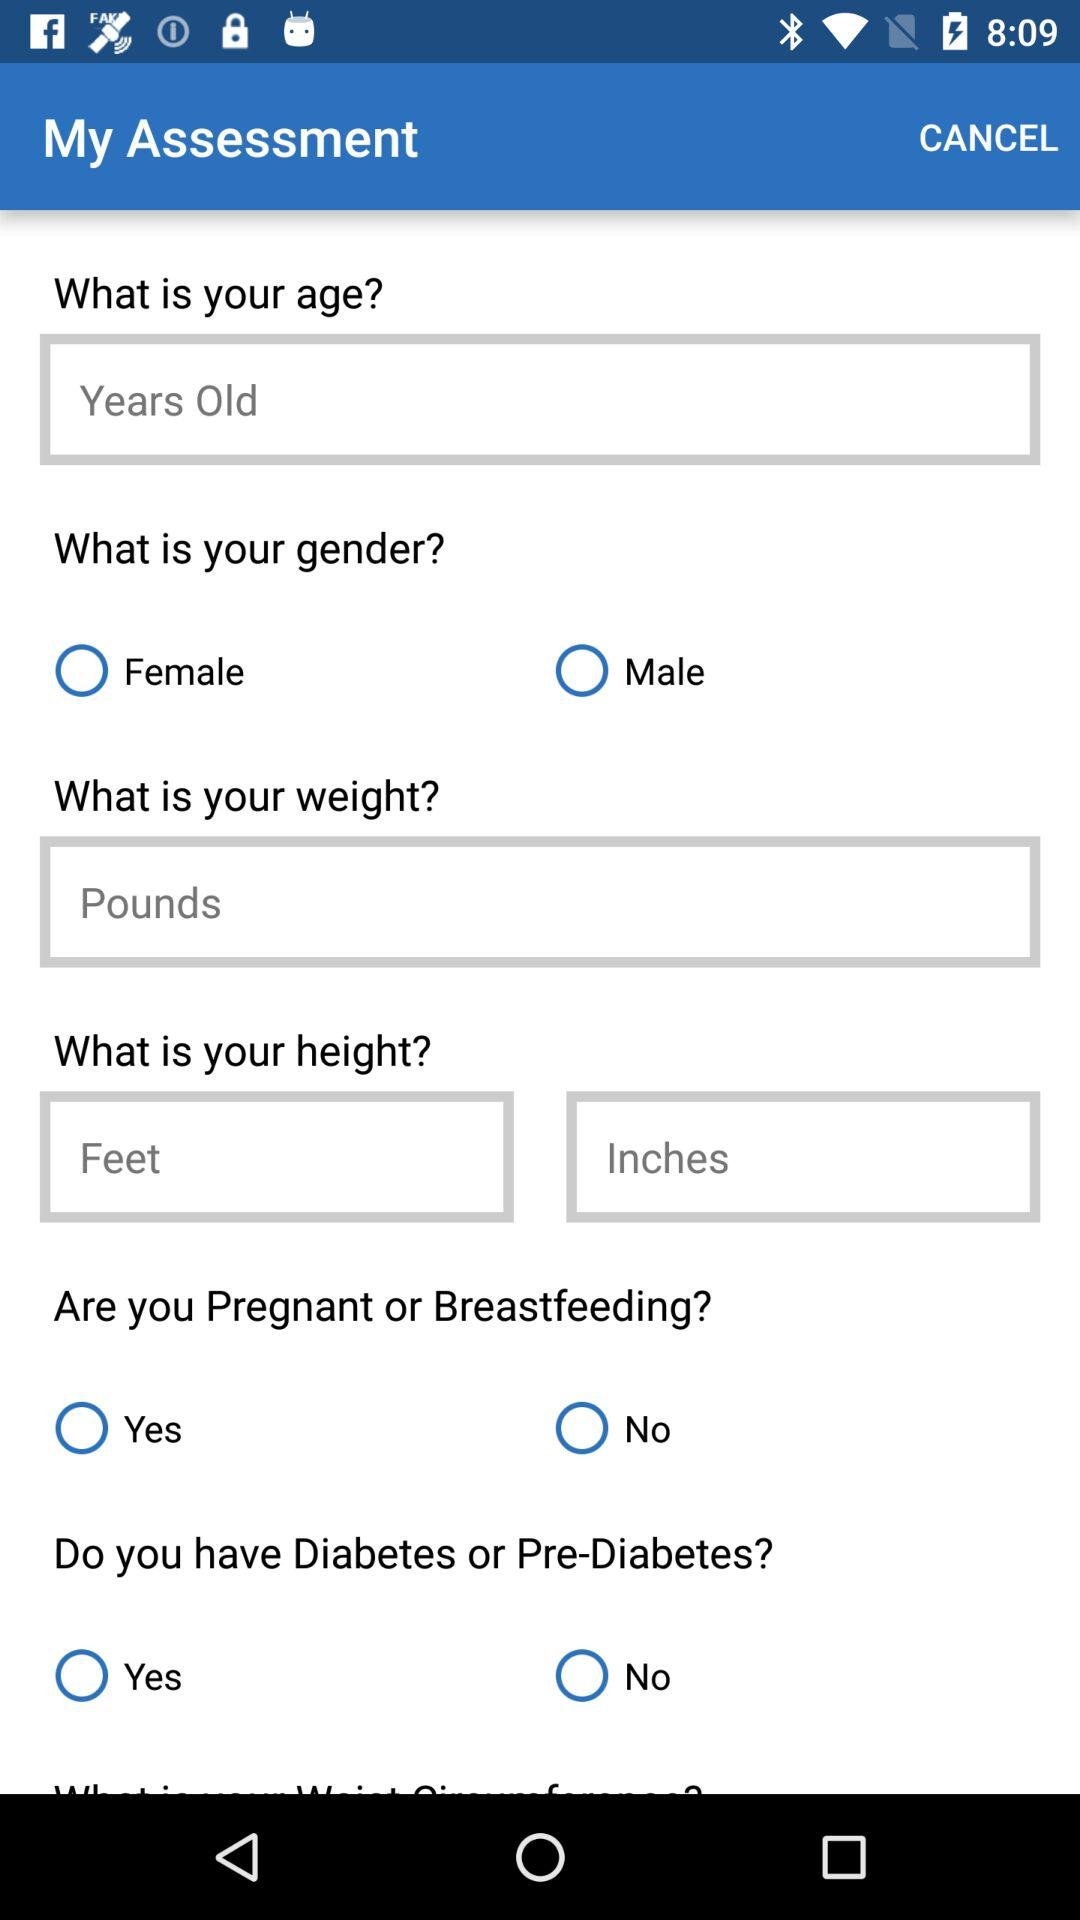What is the unit of weight? The unit of weight is the pound. 